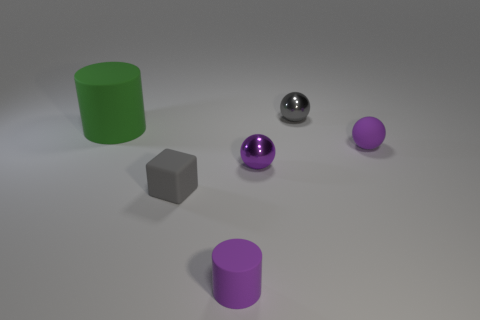There is a cylinder to the right of the small gray cube; is its color the same as the matte sphere?
Give a very brief answer. Yes. There is another matte thing that is the same shape as the large matte thing; what is its color?
Provide a short and direct response. Purple. Is there a metallic object of the same color as the rubber sphere?
Give a very brief answer. Yes. Does the small rubber sphere have the same color as the tiny rubber cylinder?
Offer a terse response. Yes. What is the shape of the thing that is the same color as the tiny matte block?
Offer a very short reply. Sphere. What number of other things are there of the same size as the rubber cube?
Provide a short and direct response. 4. The block that is in front of the shiny object in front of the matte thing that is behind the tiny purple matte sphere is what color?
Your response must be concise. Gray. There is a rubber object that is both on the left side of the rubber ball and behind the tiny rubber cube; what is its shape?
Offer a very short reply. Cylinder. How many other things are there of the same shape as the large rubber thing?
Offer a terse response. 1. The tiny purple matte thing to the right of the gray thing that is behind the matte cylinder that is on the left side of the small gray rubber cube is what shape?
Your response must be concise. Sphere. 